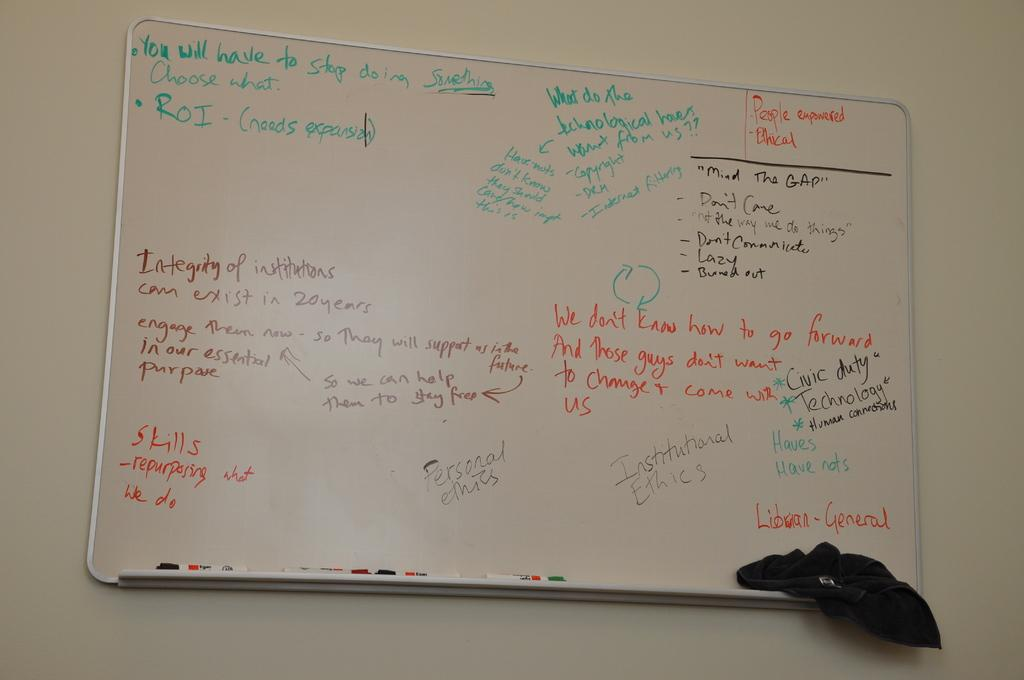<image>
Create a compact narrative representing the image presented. the word skills that is on a whiteboard 